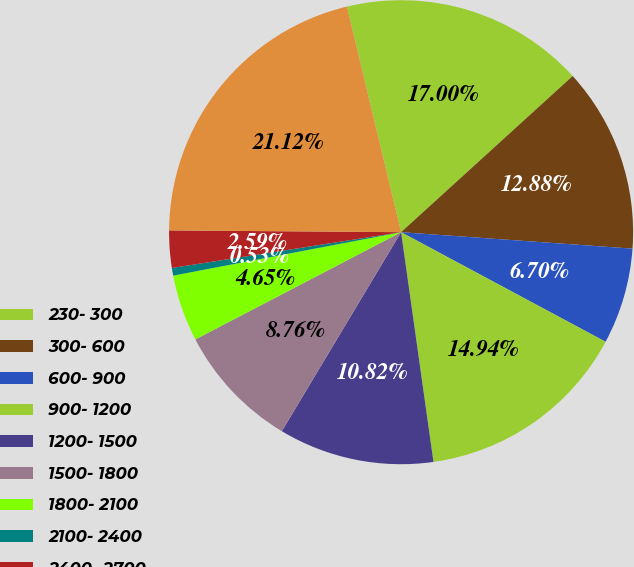<chart> <loc_0><loc_0><loc_500><loc_500><pie_chart><fcel>230- 300<fcel>300- 600<fcel>600- 900<fcel>900- 1200<fcel>1200- 1500<fcel>1500- 1800<fcel>1800- 2100<fcel>2100- 2400<fcel>2400- 2700<fcel>230- 2985<nl><fcel>17.0%<fcel>12.88%<fcel>6.7%<fcel>14.94%<fcel>10.82%<fcel>8.76%<fcel>4.65%<fcel>0.53%<fcel>2.59%<fcel>21.12%<nl></chart> 